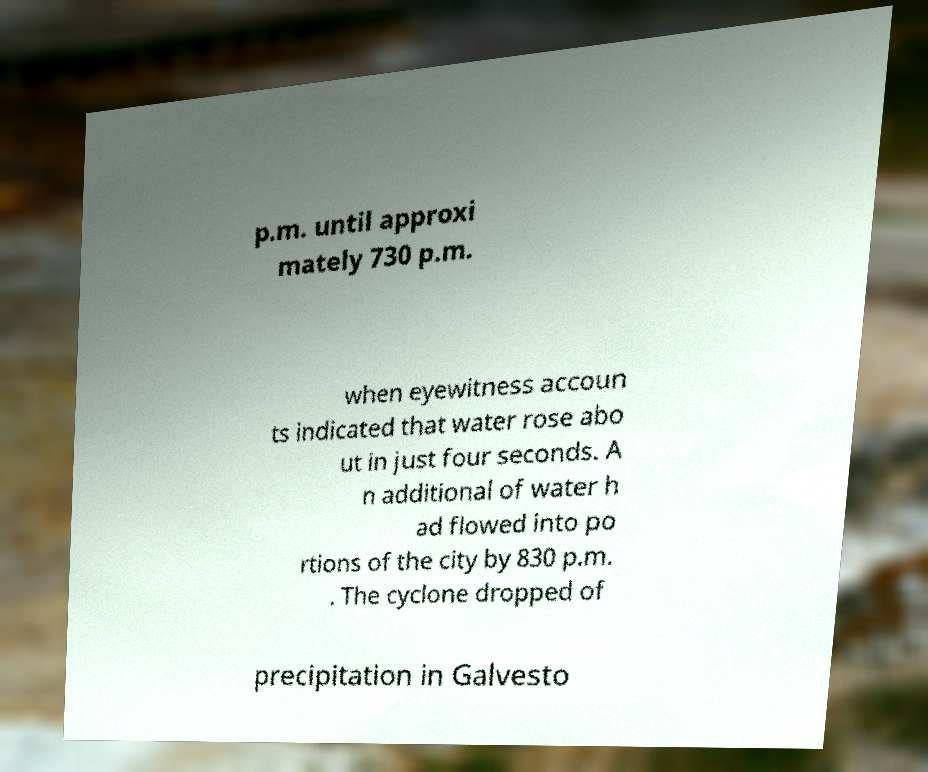Could you assist in decoding the text presented in this image and type it out clearly? p.m. until approxi mately 730 p.m. when eyewitness accoun ts indicated that water rose abo ut in just four seconds. A n additional of water h ad flowed into po rtions of the city by 830 p.m. . The cyclone dropped of precipitation in Galvesto 